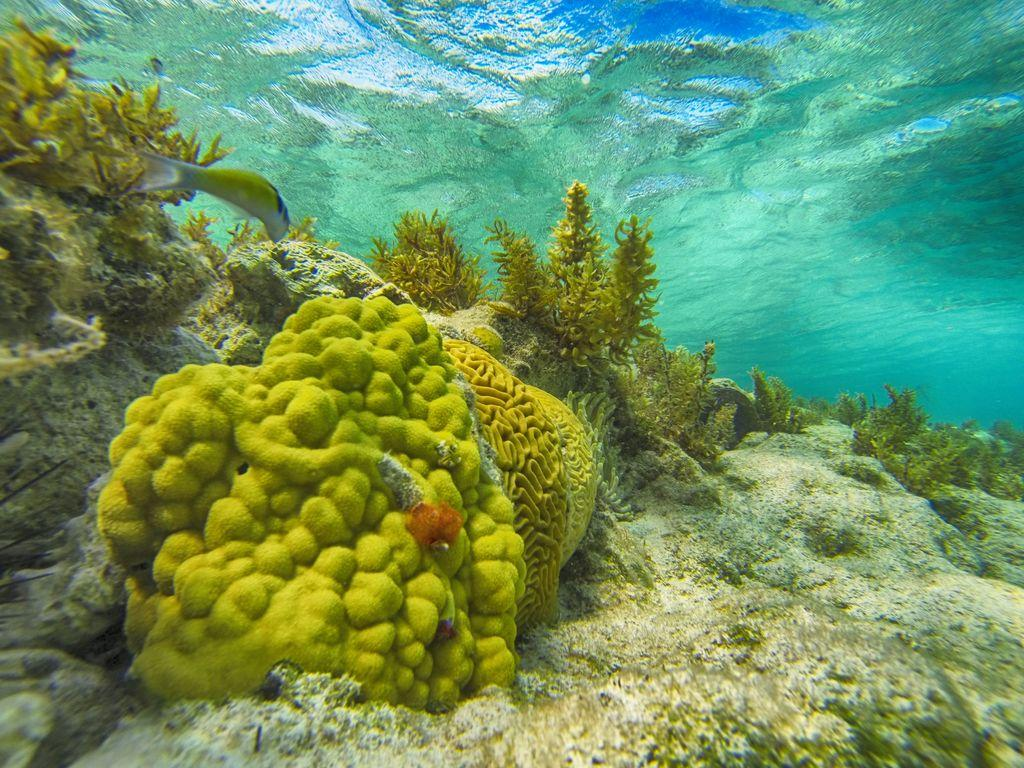What type of animal is in the image? There is a fish in the image. What is the environment in which the fish is located? There is water visible in the image. What else can be seen in the water besides the fish? There are underwater plants in the image. What decision does the fish make in the image? There is no indication in the image that the fish is making a decision, as fish do not have the ability to make decisions in the same way humans do. 